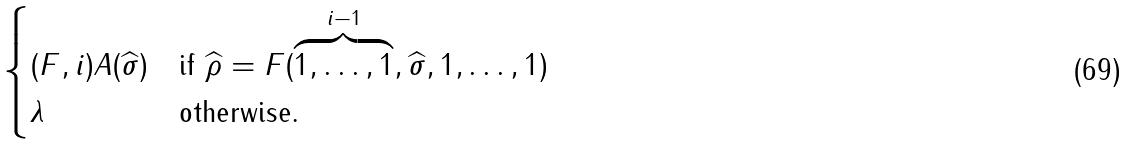Convert formula to latex. <formula><loc_0><loc_0><loc_500><loc_500>\begin{cases} ( F , i ) A ( \widehat { \sigma } ) & \text {if    $\widehat{\rho}= F(\overbrace{1,\dots,1}^{i-1},\widehat{\sigma},    1,\dots, 1)$} \\ \lambda & \text {otherwise.} \end{cases}</formula> 